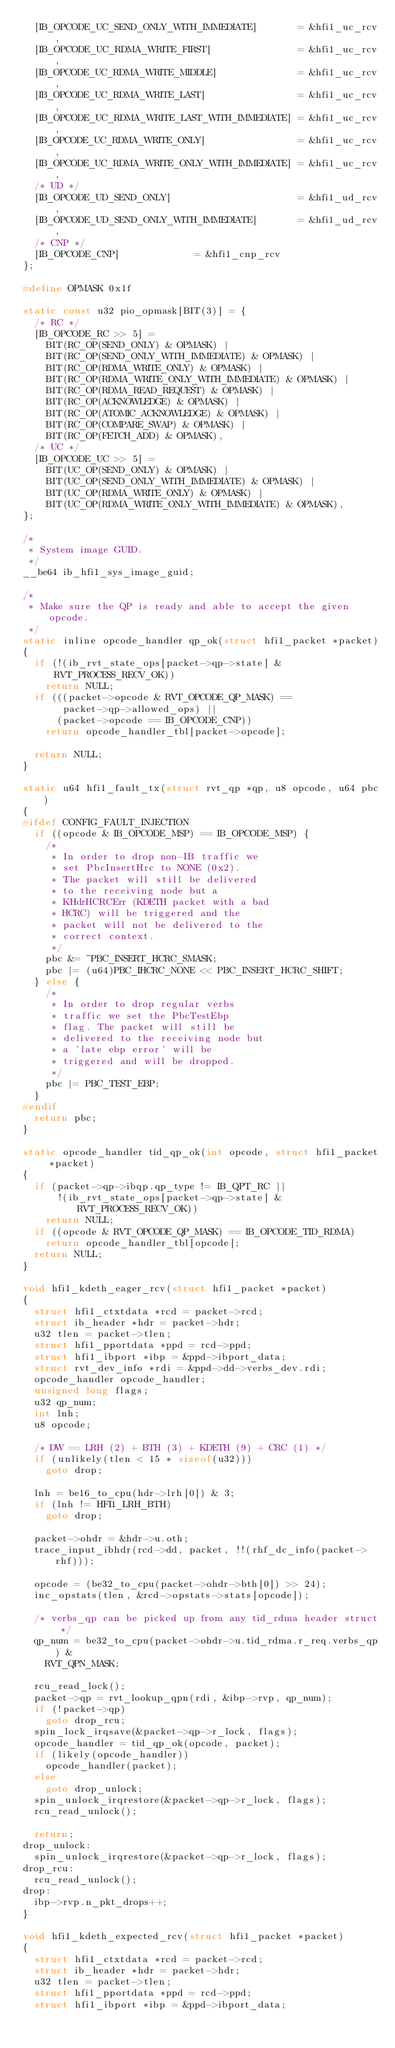<code> <loc_0><loc_0><loc_500><loc_500><_C_>	[IB_OPCODE_UC_SEND_ONLY_WITH_IMMEDIATE]       = &hfi1_uc_rcv,
	[IB_OPCODE_UC_RDMA_WRITE_FIRST]               = &hfi1_uc_rcv,
	[IB_OPCODE_UC_RDMA_WRITE_MIDDLE]              = &hfi1_uc_rcv,
	[IB_OPCODE_UC_RDMA_WRITE_LAST]                = &hfi1_uc_rcv,
	[IB_OPCODE_UC_RDMA_WRITE_LAST_WITH_IMMEDIATE] = &hfi1_uc_rcv,
	[IB_OPCODE_UC_RDMA_WRITE_ONLY]                = &hfi1_uc_rcv,
	[IB_OPCODE_UC_RDMA_WRITE_ONLY_WITH_IMMEDIATE] = &hfi1_uc_rcv,
	/* UD */
	[IB_OPCODE_UD_SEND_ONLY]                      = &hfi1_ud_rcv,
	[IB_OPCODE_UD_SEND_ONLY_WITH_IMMEDIATE]       = &hfi1_ud_rcv,
	/* CNP */
	[IB_OPCODE_CNP]				      = &hfi1_cnp_rcv
};

#define OPMASK 0x1f

static const u32 pio_opmask[BIT(3)] = {
	/* RC */
	[IB_OPCODE_RC >> 5] =
		BIT(RC_OP(SEND_ONLY) & OPMASK) |
		BIT(RC_OP(SEND_ONLY_WITH_IMMEDIATE) & OPMASK) |
		BIT(RC_OP(RDMA_WRITE_ONLY) & OPMASK) |
		BIT(RC_OP(RDMA_WRITE_ONLY_WITH_IMMEDIATE) & OPMASK) |
		BIT(RC_OP(RDMA_READ_REQUEST) & OPMASK) |
		BIT(RC_OP(ACKNOWLEDGE) & OPMASK) |
		BIT(RC_OP(ATOMIC_ACKNOWLEDGE) & OPMASK) |
		BIT(RC_OP(COMPARE_SWAP) & OPMASK) |
		BIT(RC_OP(FETCH_ADD) & OPMASK),
	/* UC */
	[IB_OPCODE_UC >> 5] =
		BIT(UC_OP(SEND_ONLY) & OPMASK) |
		BIT(UC_OP(SEND_ONLY_WITH_IMMEDIATE) & OPMASK) |
		BIT(UC_OP(RDMA_WRITE_ONLY) & OPMASK) |
		BIT(UC_OP(RDMA_WRITE_ONLY_WITH_IMMEDIATE) & OPMASK),
};

/*
 * System image GUID.
 */
__be64 ib_hfi1_sys_image_guid;

/*
 * Make sure the QP is ready and able to accept the given opcode.
 */
static inline opcode_handler qp_ok(struct hfi1_packet *packet)
{
	if (!(ib_rvt_state_ops[packet->qp->state] & RVT_PROCESS_RECV_OK))
		return NULL;
	if (((packet->opcode & RVT_OPCODE_QP_MASK) ==
	     packet->qp->allowed_ops) ||
	    (packet->opcode == IB_OPCODE_CNP))
		return opcode_handler_tbl[packet->opcode];

	return NULL;
}

static u64 hfi1_fault_tx(struct rvt_qp *qp, u8 opcode, u64 pbc)
{
#ifdef CONFIG_FAULT_INJECTION
	if ((opcode & IB_OPCODE_MSP) == IB_OPCODE_MSP) {
		/*
		 * In order to drop non-IB traffic we
		 * set PbcInsertHrc to NONE (0x2).
		 * The packet will still be delivered
		 * to the receiving node but a
		 * KHdrHCRCErr (KDETH packet with a bad
		 * HCRC) will be triggered and the
		 * packet will not be delivered to the
		 * correct context.
		 */
		pbc &= ~PBC_INSERT_HCRC_SMASK;
		pbc |= (u64)PBC_IHCRC_NONE << PBC_INSERT_HCRC_SHIFT;
	} else {
		/*
		 * In order to drop regular verbs
		 * traffic we set the PbcTestEbp
		 * flag. The packet will still be
		 * delivered to the receiving node but
		 * a 'late ebp error' will be
		 * triggered and will be dropped.
		 */
		pbc |= PBC_TEST_EBP;
	}
#endif
	return pbc;
}

static opcode_handler tid_qp_ok(int opcode, struct hfi1_packet *packet)
{
	if (packet->qp->ibqp.qp_type != IB_QPT_RC ||
	    !(ib_rvt_state_ops[packet->qp->state] & RVT_PROCESS_RECV_OK))
		return NULL;
	if ((opcode & RVT_OPCODE_QP_MASK) == IB_OPCODE_TID_RDMA)
		return opcode_handler_tbl[opcode];
	return NULL;
}

void hfi1_kdeth_eager_rcv(struct hfi1_packet *packet)
{
	struct hfi1_ctxtdata *rcd = packet->rcd;
	struct ib_header *hdr = packet->hdr;
	u32 tlen = packet->tlen;
	struct hfi1_pportdata *ppd = rcd->ppd;
	struct hfi1_ibport *ibp = &ppd->ibport_data;
	struct rvt_dev_info *rdi = &ppd->dd->verbs_dev.rdi;
	opcode_handler opcode_handler;
	unsigned long flags;
	u32 qp_num;
	int lnh;
	u8 opcode;

	/* DW == LRH (2) + BTH (3) + KDETH (9) + CRC (1) */
	if (unlikely(tlen < 15 * sizeof(u32)))
		goto drop;

	lnh = be16_to_cpu(hdr->lrh[0]) & 3;
	if (lnh != HFI1_LRH_BTH)
		goto drop;

	packet->ohdr = &hdr->u.oth;
	trace_input_ibhdr(rcd->dd, packet, !!(rhf_dc_info(packet->rhf)));

	opcode = (be32_to_cpu(packet->ohdr->bth[0]) >> 24);
	inc_opstats(tlen, &rcd->opstats->stats[opcode]);

	/* verbs_qp can be picked up from any tid_rdma header struct */
	qp_num = be32_to_cpu(packet->ohdr->u.tid_rdma.r_req.verbs_qp) &
		RVT_QPN_MASK;

	rcu_read_lock();
	packet->qp = rvt_lookup_qpn(rdi, &ibp->rvp, qp_num);
	if (!packet->qp)
		goto drop_rcu;
	spin_lock_irqsave(&packet->qp->r_lock, flags);
	opcode_handler = tid_qp_ok(opcode, packet);
	if (likely(opcode_handler))
		opcode_handler(packet);
	else
		goto drop_unlock;
	spin_unlock_irqrestore(&packet->qp->r_lock, flags);
	rcu_read_unlock();

	return;
drop_unlock:
	spin_unlock_irqrestore(&packet->qp->r_lock, flags);
drop_rcu:
	rcu_read_unlock();
drop:
	ibp->rvp.n_pkt_drops++;
}

void hfi1_kdeth_expected_rcv(struct hfi1_packet *packet)
{
	struct hfi1_ctxtdata *rcd = packet->rcd;
	struct ib_header *hdr = packet->hdr;
	u32 tlen = packet->tlen;
	struct hfi1_pportdata *ppd = rcd->ppd;
	struct hfi1_ibport *ibp = &ppd->ibport_data;</code> 